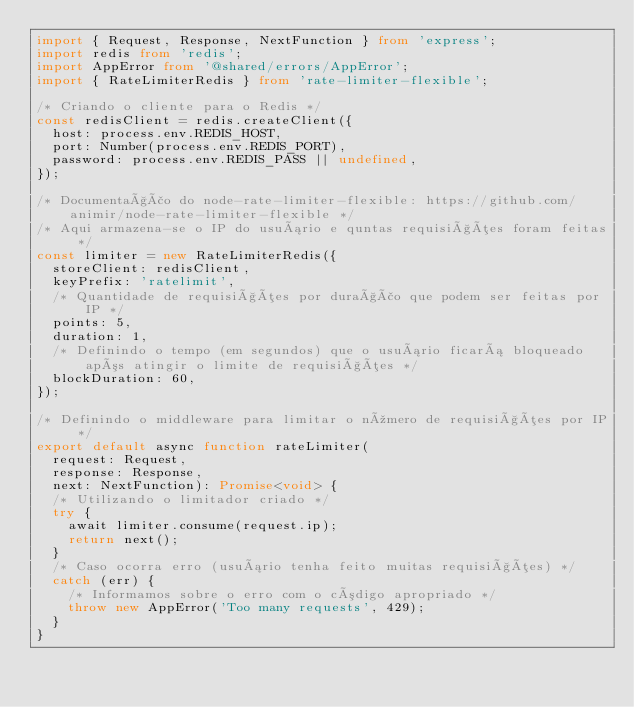Convert code to text. <code><loc_0><loc_0><loc_500><loc_500><_TypeScript_>import { Request, Response, NextFunction } from 'express';
import redis from 'redis';
import AppError from '@shared/errors/AppError';
import { RateLimiterRedis } from 'rate-limiter-flexible';

/* Criando o cliente para o Redis */
const redisClient = redis.createClient({
  host: process.env.REDIS_HOST,
  port: Number(process.env.REDIS_PORT),
  password: process.env.REDIS_PASS || undefined,
});

/* Documentação do node-rate-limiter-flexible: https://github.com/animir/node-rate-limiter-flexible */
/* Aqui armazena-se o IP do usuário e quntas requisições foram feitas */
const limiter = new RateLimiterRedis({
  storeClient: redisClient,
  keyPrefix: 'ratelimit',
  /* Quantidade de requisições por duração que podem ser feitas por IP */
  points: 5,
  duration: 1,
  /* Definindo o tempo (em segundos) que o usuário ficará bloqueado após atingir o limite de requisições */
  blockDuration: 60,
});

/* Definindo o middleware para limitar o número de requisições por IP */
export default async function rateLimiter(
  request: Request,
  response: Response,
  next: NextFunction): Promise<void> {
  /* Utilizando o limitador criado */
  try {
    await limiter.consume(request.ip);
    return next();
  }
  /* Caso ocorra erro (usuário tenha feito muitas requisições) */
  catch (err) {
    /* Informamos sobre o erro com o código apropriado */
    throw new AppError('Too many requests', 429);
  }
}
</code> 